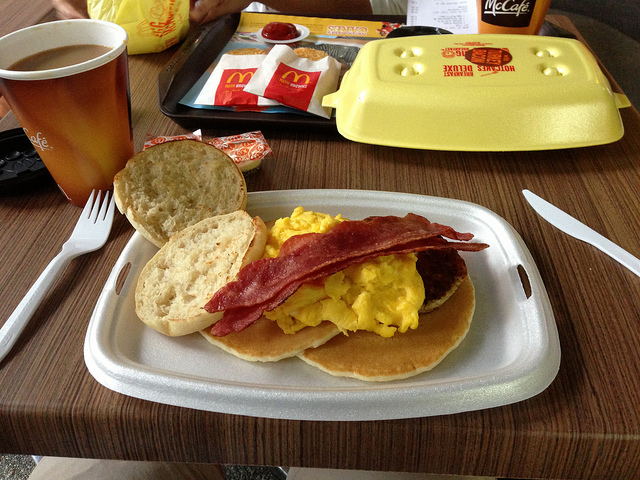Identify and read out the text in this image. DELUXE McCaf&#233; M M 